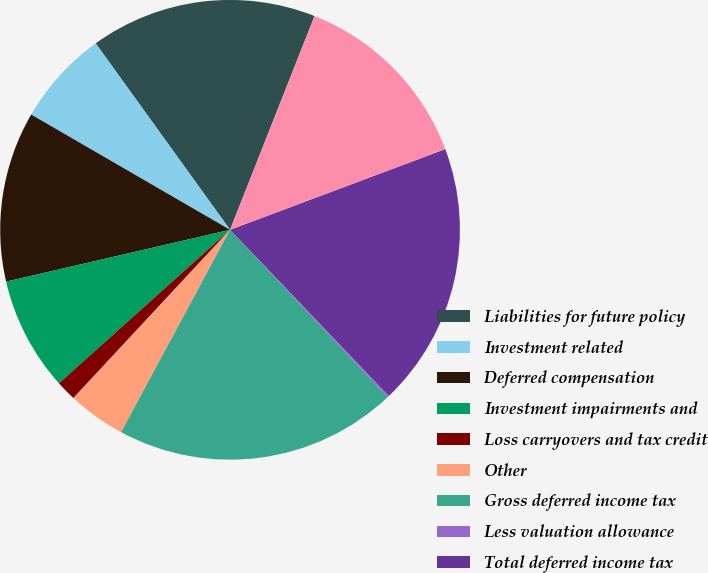Convert chart. <chart><loc_0><loc_0><loc_500><loc_500><pie_chart><fcel>Liabilities for future policy<fcel>Investment related<fcel>Deferred compensation<fcel>Investment impairments and<fcel>Loss carryovers and tax credit<fcel>Other<fcel>Gross deferred income tax<fcel>Less valuation allowance<fcel>Total deferred income tax<fcel>Deferred acquisition costs<nl><fcel>15.93%<fcel>6.7%<fcel>11.98%<fcel>8.02%<fcel>1.43%<fcel>4.07%<fcel>19.89%<fcel>0.11%<fcel>18.57%<fcel>13.3%<nl></chart> 